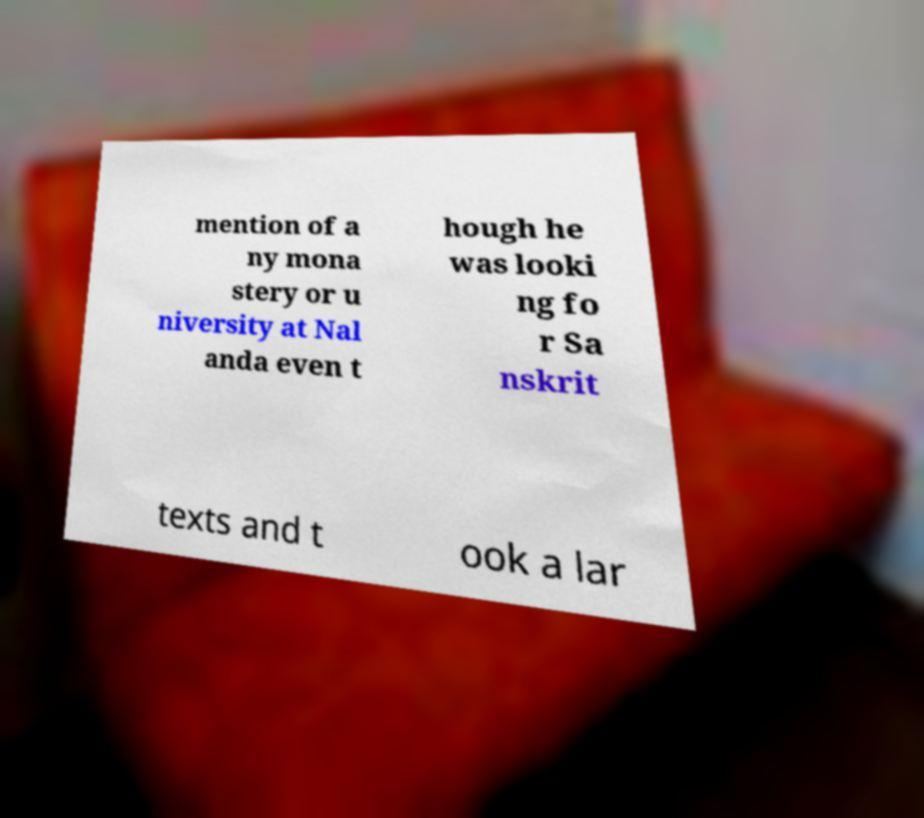For documentation purposes, I need the text within this image transcribed. Could you provide that? mention of a ny mona stery or u niversity at Nal anda even t hough he was looki ng fo r Sa nskrit texts and t ook a lar 